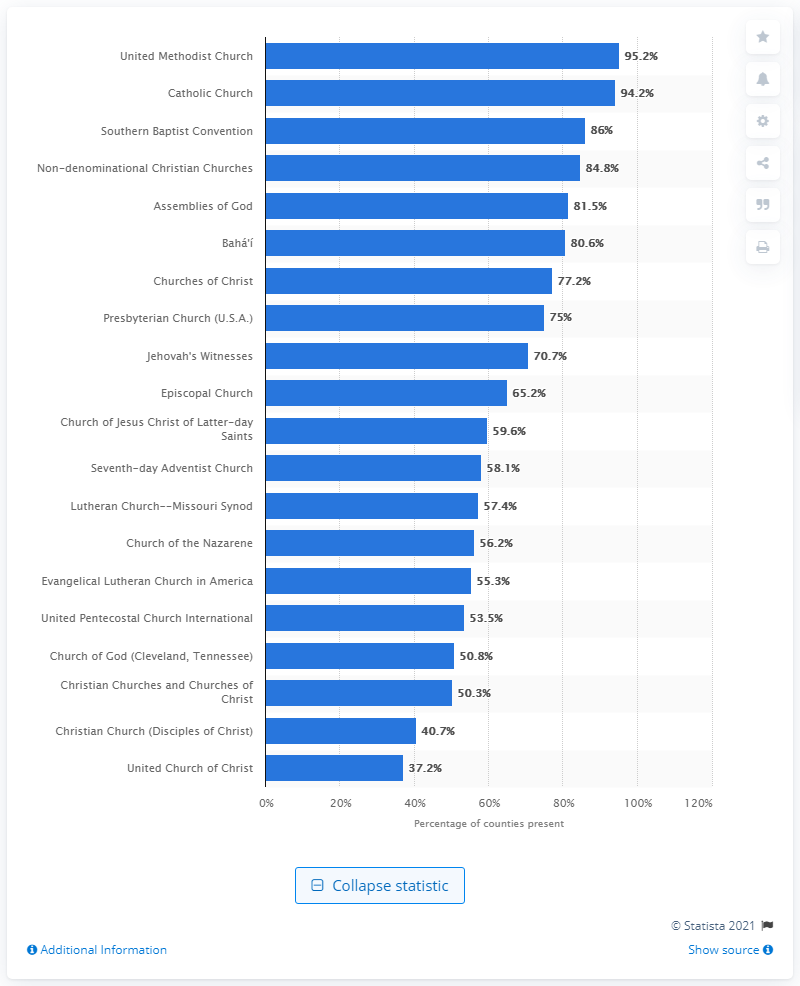Identify some key points in this picture. In 2010, the United Methodist Church was present in 95.2% of all American counties. 